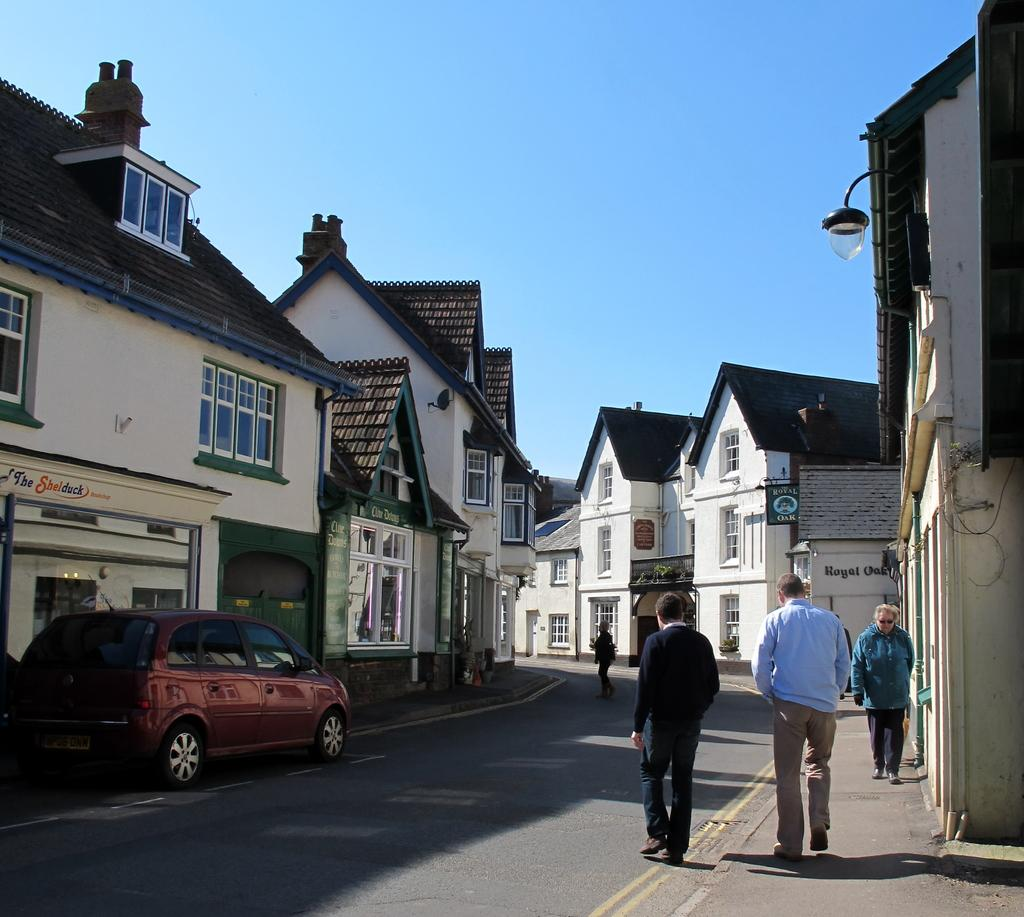How many people are walking on the street in the image? There are four people walking on the street in the image. What color is the car parked on the left side? The car parked on the left side is red. What material are the houses made of in the image? The houses in the image are made of wood. What can be seen on the right side of the image? There is a lamppost on the right side of the image. What type of root is growing on the lamppost in the image? There is no root growing on the lamppost in the image. Who is guiding the people walking on the street in the image? There is no guide present in the image; the people are walking on their own. 